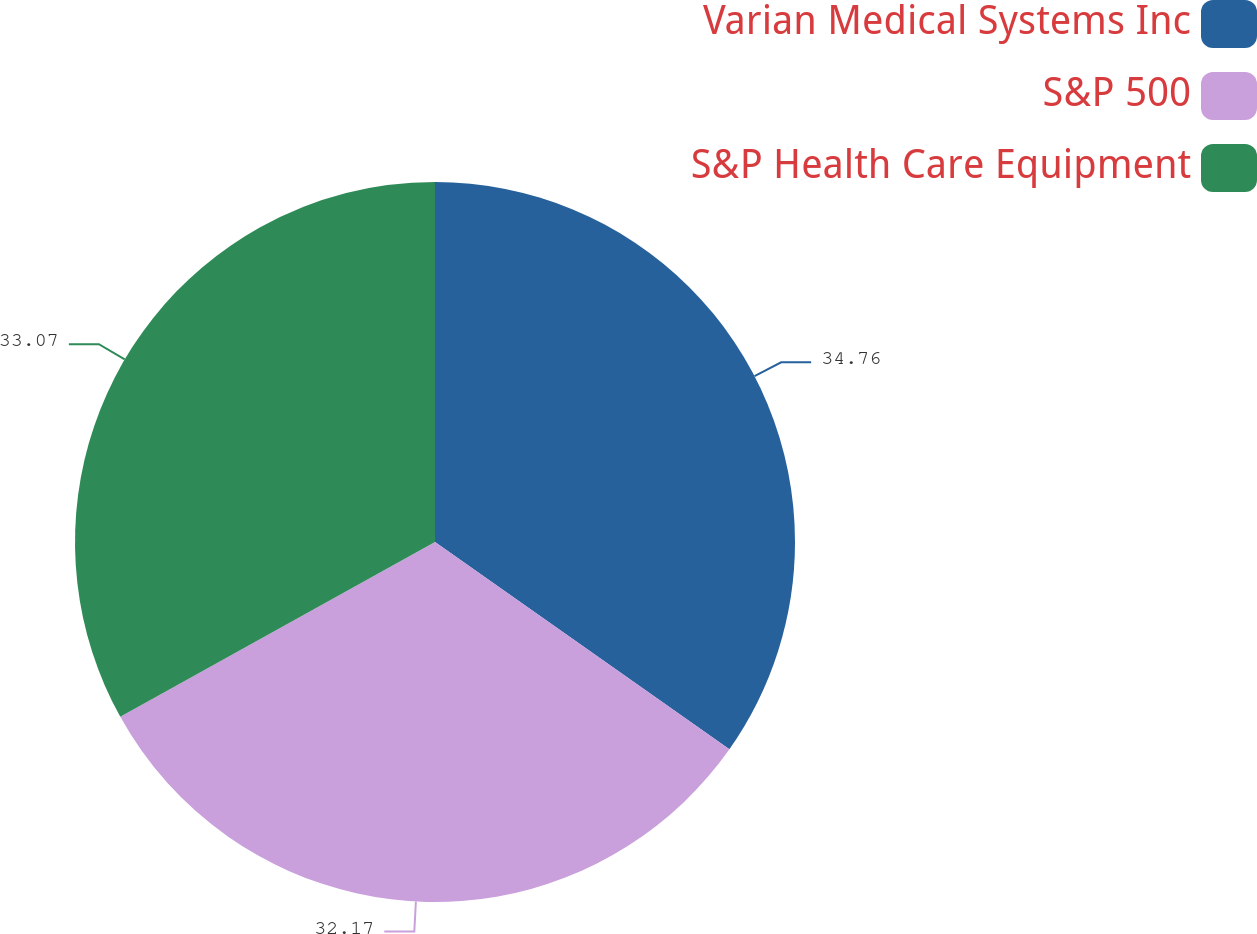Convert chart. <chart><loc_0><loc_0><loc_500><loc_500><pie_chart><fcel>Varian Medical Systems Inc<fcel>S&P 500<fcel>S&P Health Care Equipment<nl><fcel>34.76%<fcel>32.17%<fcel>33.07%<nl></chart> 